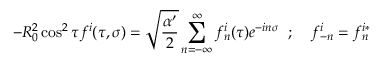<formula> <loc_0><loc_0><loc_500><loc_500>- R _ { 0 } ^ { 2 } \cos ^ { 2 } \tau f ^ { i } ( \tau , \sigma ) = \sqrt { \frac { \alpha ^ { \prime } } { 2 } } \sum _ { n = - \infty } ^ { \infty } f _ { n } ^ { i } ( \tau ) e ^ { - i n \sigma } \, ; \, f _ { - n } ^ { i } = f _ { n } ^ { i * }</formula> 